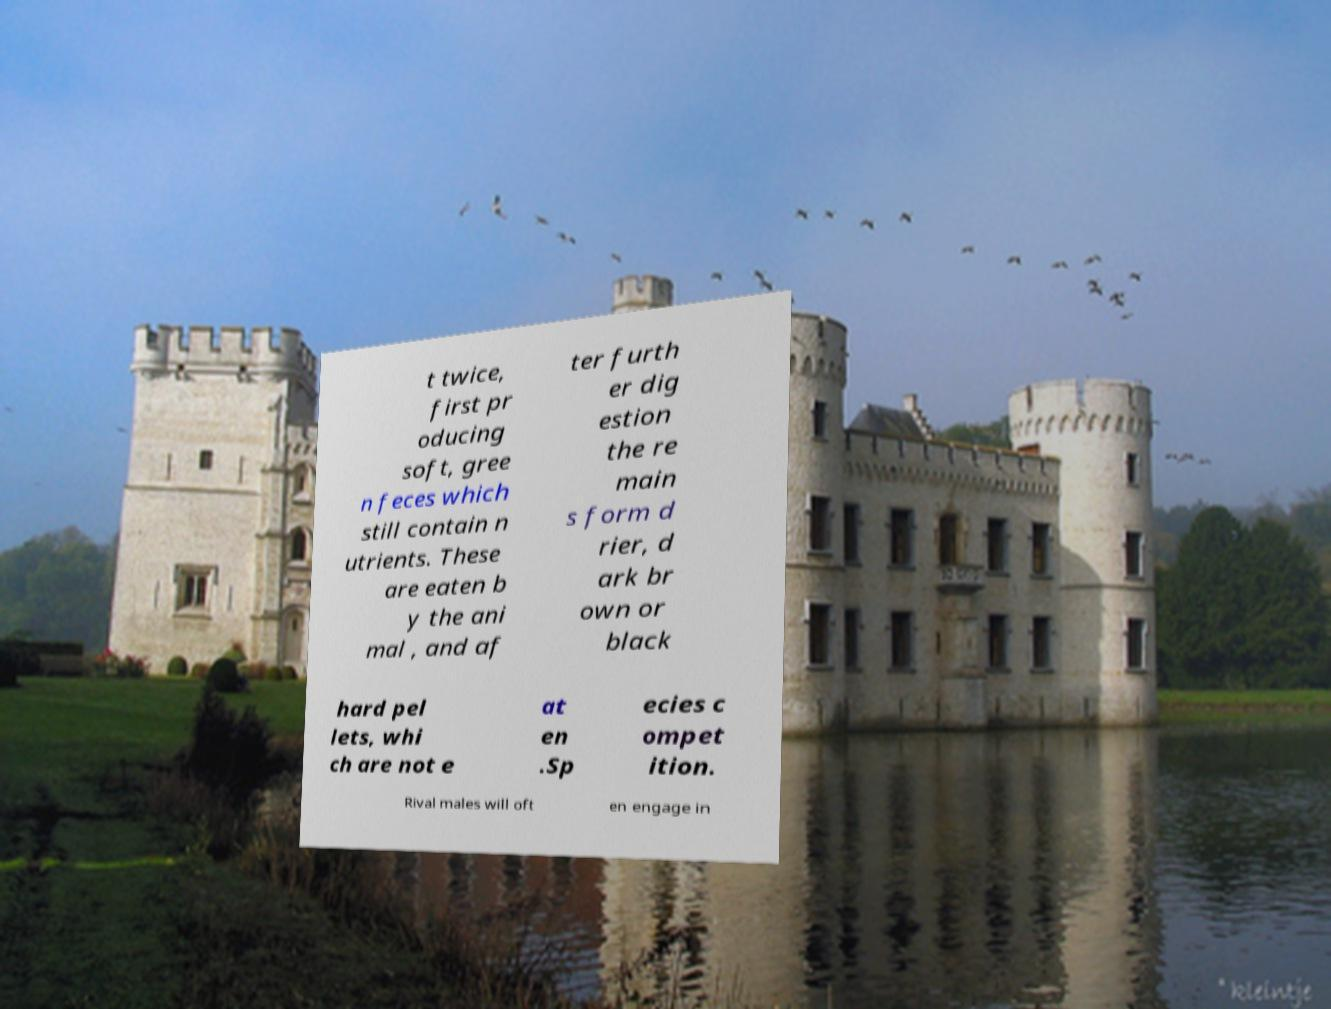I need the written content from this picture converted into text. Can you do that? t twice, first pr oducing soft, gree n feces which still contain n utrients. These are eaten b y the ani mal , and af ter furth er dig estion the re main s form d rier, d ark br own or black hard pel lets, whi ch are not e at en .Sp ecies c ompet ition. Rival males will oft en engage in 